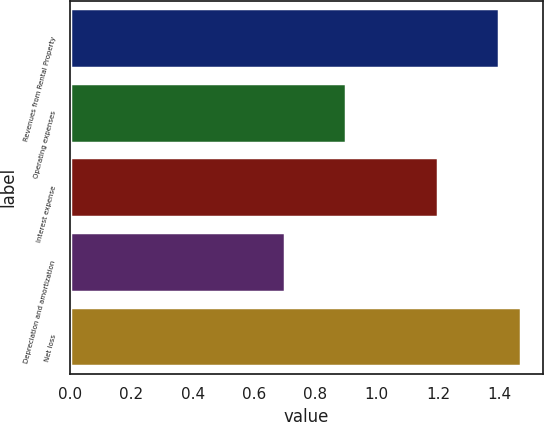Convert chart to OTSL. <chart><loc_0><loc_0><loc_500><loc_500><bar_chart><fcel>Revenues from Rental Property<fcel>Operating expenses<fcel>Interest expense<fcel>Depreciation and amortization<fcel>Net loss<nl><fcel>1.4<fcel>0.9<fcel>1.2<fcel>0.7<fcel>1.47<nl></chart> 